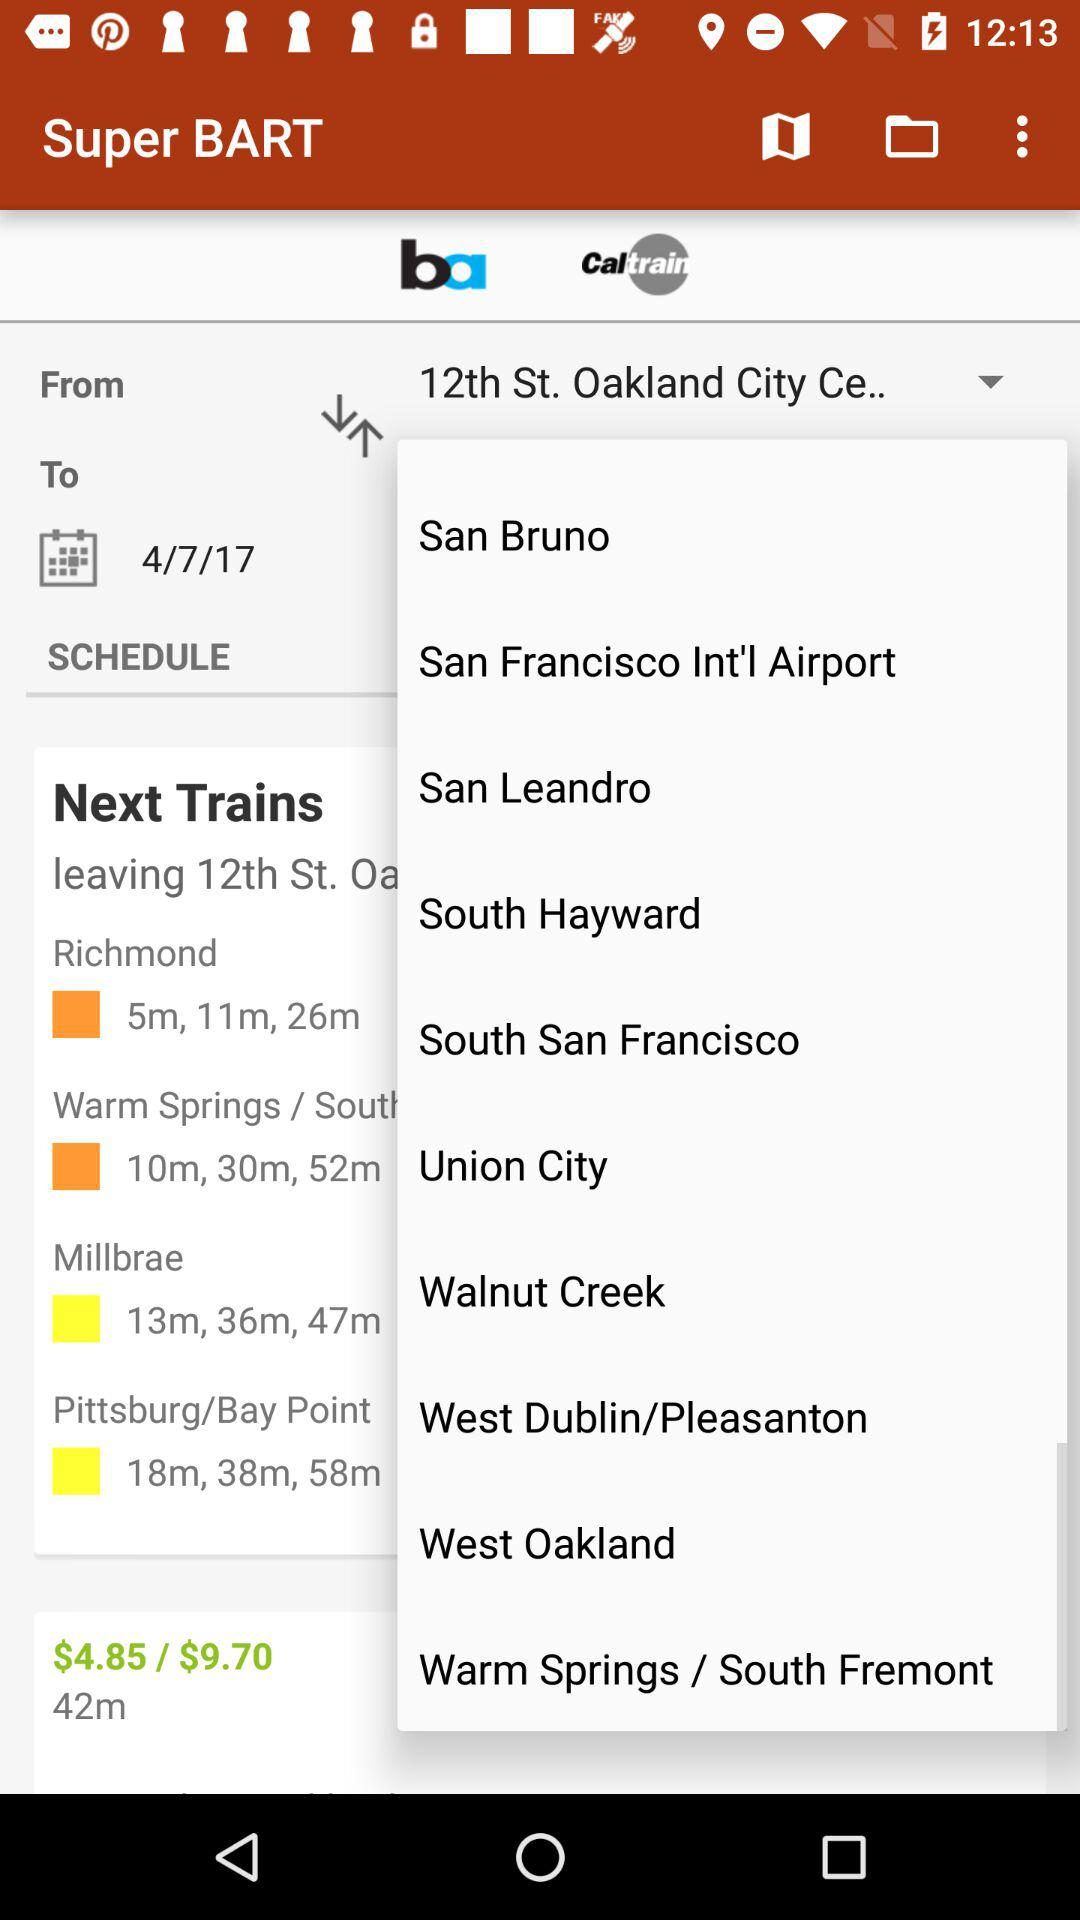What is the selected date? The selected date is 4/7/17. 